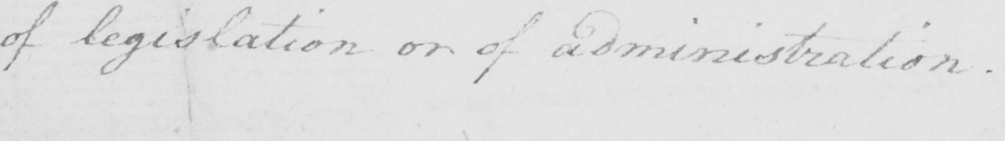Please transcribe the handwritten text in this image. of legislation or of administration . 